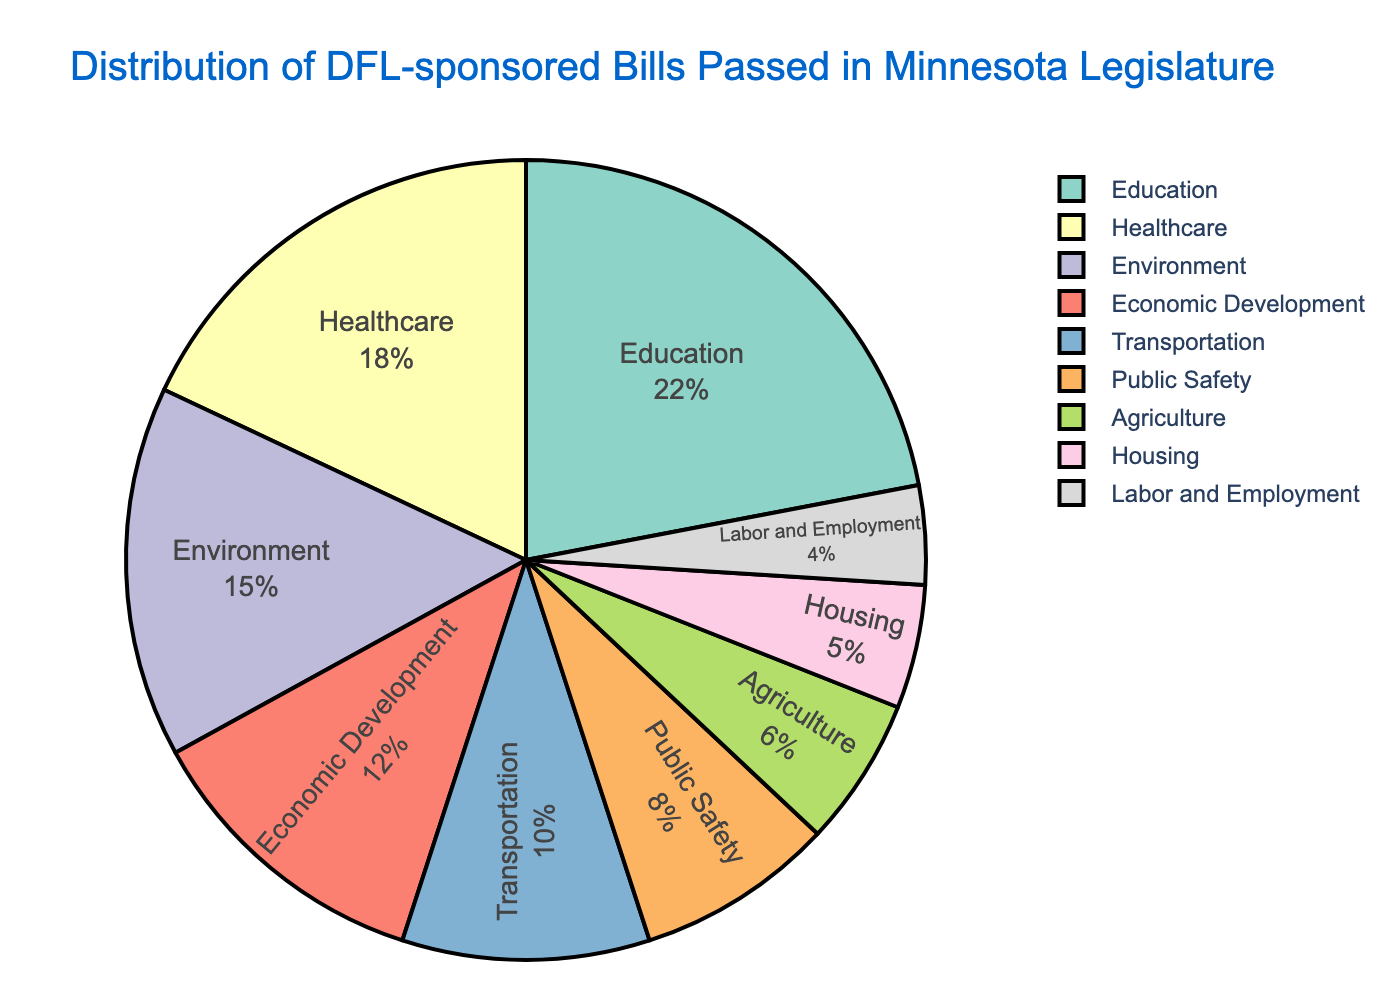What policy area has the highest percentage of DFL-sponsored bills passed? The pie chart shows that the policy area with the largest portion is Education with 22%.
Answer: Education What is the combined percentage of DFL-sponsored bills passed in Healthcare and Environment? From the data, Healthcare accounts for 18% and Environment for 15%. Adding these together gives 18% + 15% = 33%.
Answer: 33% Is the percentage of bills passed in Transportation greater than in Public Safety? The pie chart shows Transportation at 10% and Public Safety at 8%. 10% is greater than 8%.
Answer: Yes Which policy area accounts for the smallest percentage on the pie chart? According to the chart, Labor and Employment has the smallest slice at 4%.
Answer: Labor and Employment What is the difference in percentage between bills passed in Education and Economic Development? Education accounts for 22% and Economic Development 12%. Subtracting these gives 22% - 12% = 10%.
Answer: 10% Are the combined percentages of Housing and Labor and Employment less than the percentage of Environment? Housing is 5% and Labor and Employment is 4%. Adding these together gives 5% + 4% = 9%. Environment is 15%, so 9% is less than 15%.
Answer: Yes What is the cumulative percentage for Agriculture, Housing, and Labor and Employment? Adding the percentages for Agriculture (6%), Housing (5%), and Labor and Employment (4%) gives 6% + 5% + 4% = 15%.
Answer: 15% Which policy areas have a percentage less than 10% each? The chart shows Public Safety (8%), Agriculture (6%), Housing (5%), and Labor and Employment (4%) all have less than 10%.
Answer: Public Safety, Agriculture, Housing, Labor and Employment Is the percentage for Economic Development closer to Healthcare or to Transportation? Economic Development is at 12%, Healthcare at 18%, and Transportation at 10%. The difference between Economic Development and Healthcare is 6% (18% - 12%), and the difference between Economic Development and Transportation is 2% (12% - 10%). Thus, it is closer to Transportation.
Answer: Transportation What is the combined percentage of the three largest policy areas? The three largest policy areas are Education (22%), Healthcare (18%), and Environment (15%). Adding these together gives 22% + 18% + 15% = 55%.
Answer: 55% 